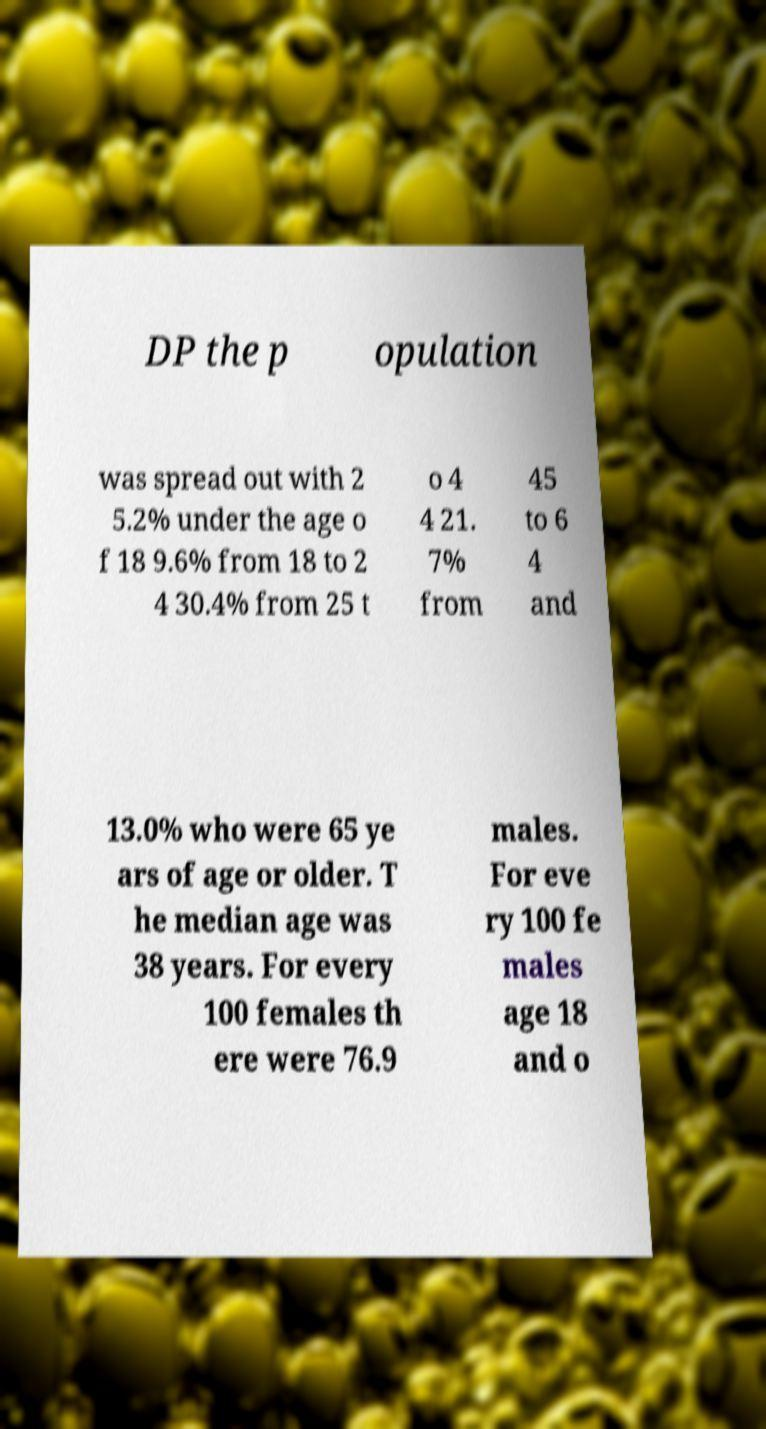Can you accurately transcribe the text from the provided image for me? DP the p opulation was spread out with 2 5.2% under the age o f 18 9.6% from 18 to 2 4 30.4% from 25 t o 4 4 21. 7% from 45 to 6 4 and 13.0% who were 65 ye ars of age or older. T he median age was 38 years. For every 100 females th ere were 76.9 males. For eve ry 100 fe males age 18 and o 